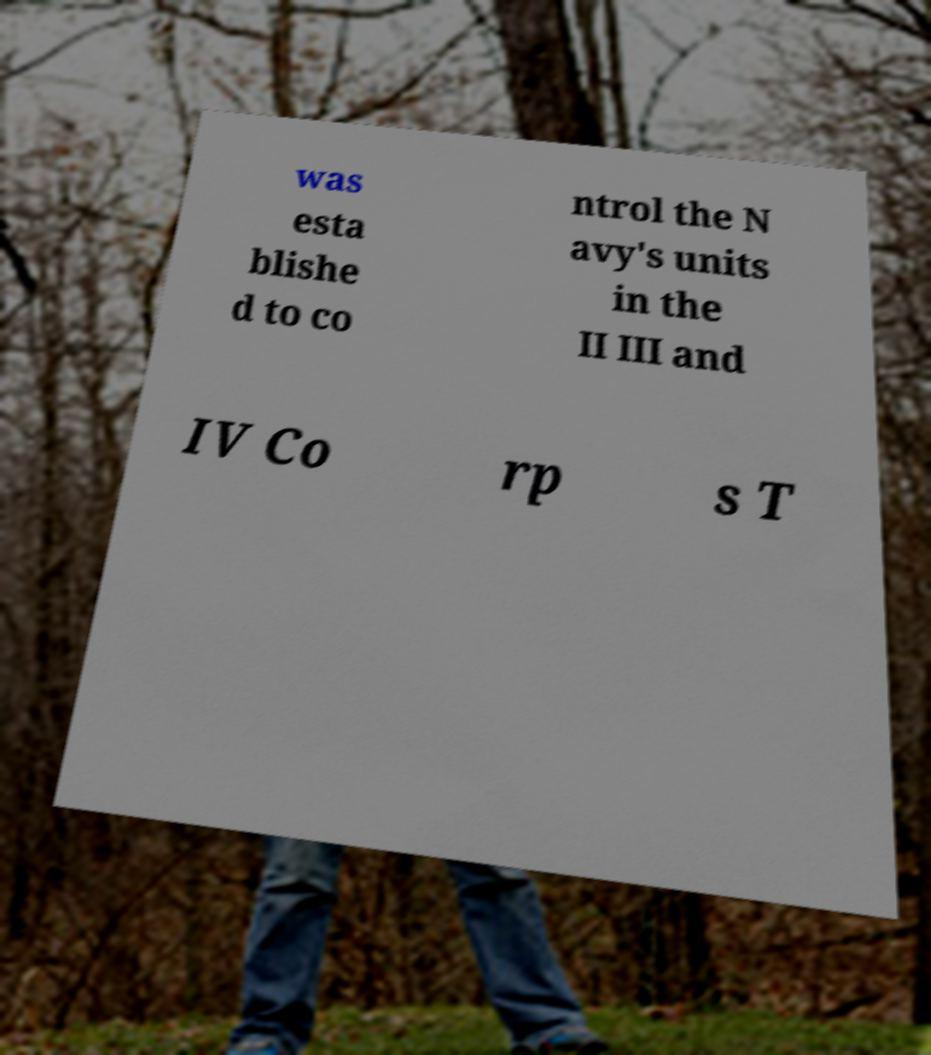I need the written content from this picture converted into text. Can you do that? was esta blishe d to co ntrol the N avy's units in the II III and IV Co rp s T 